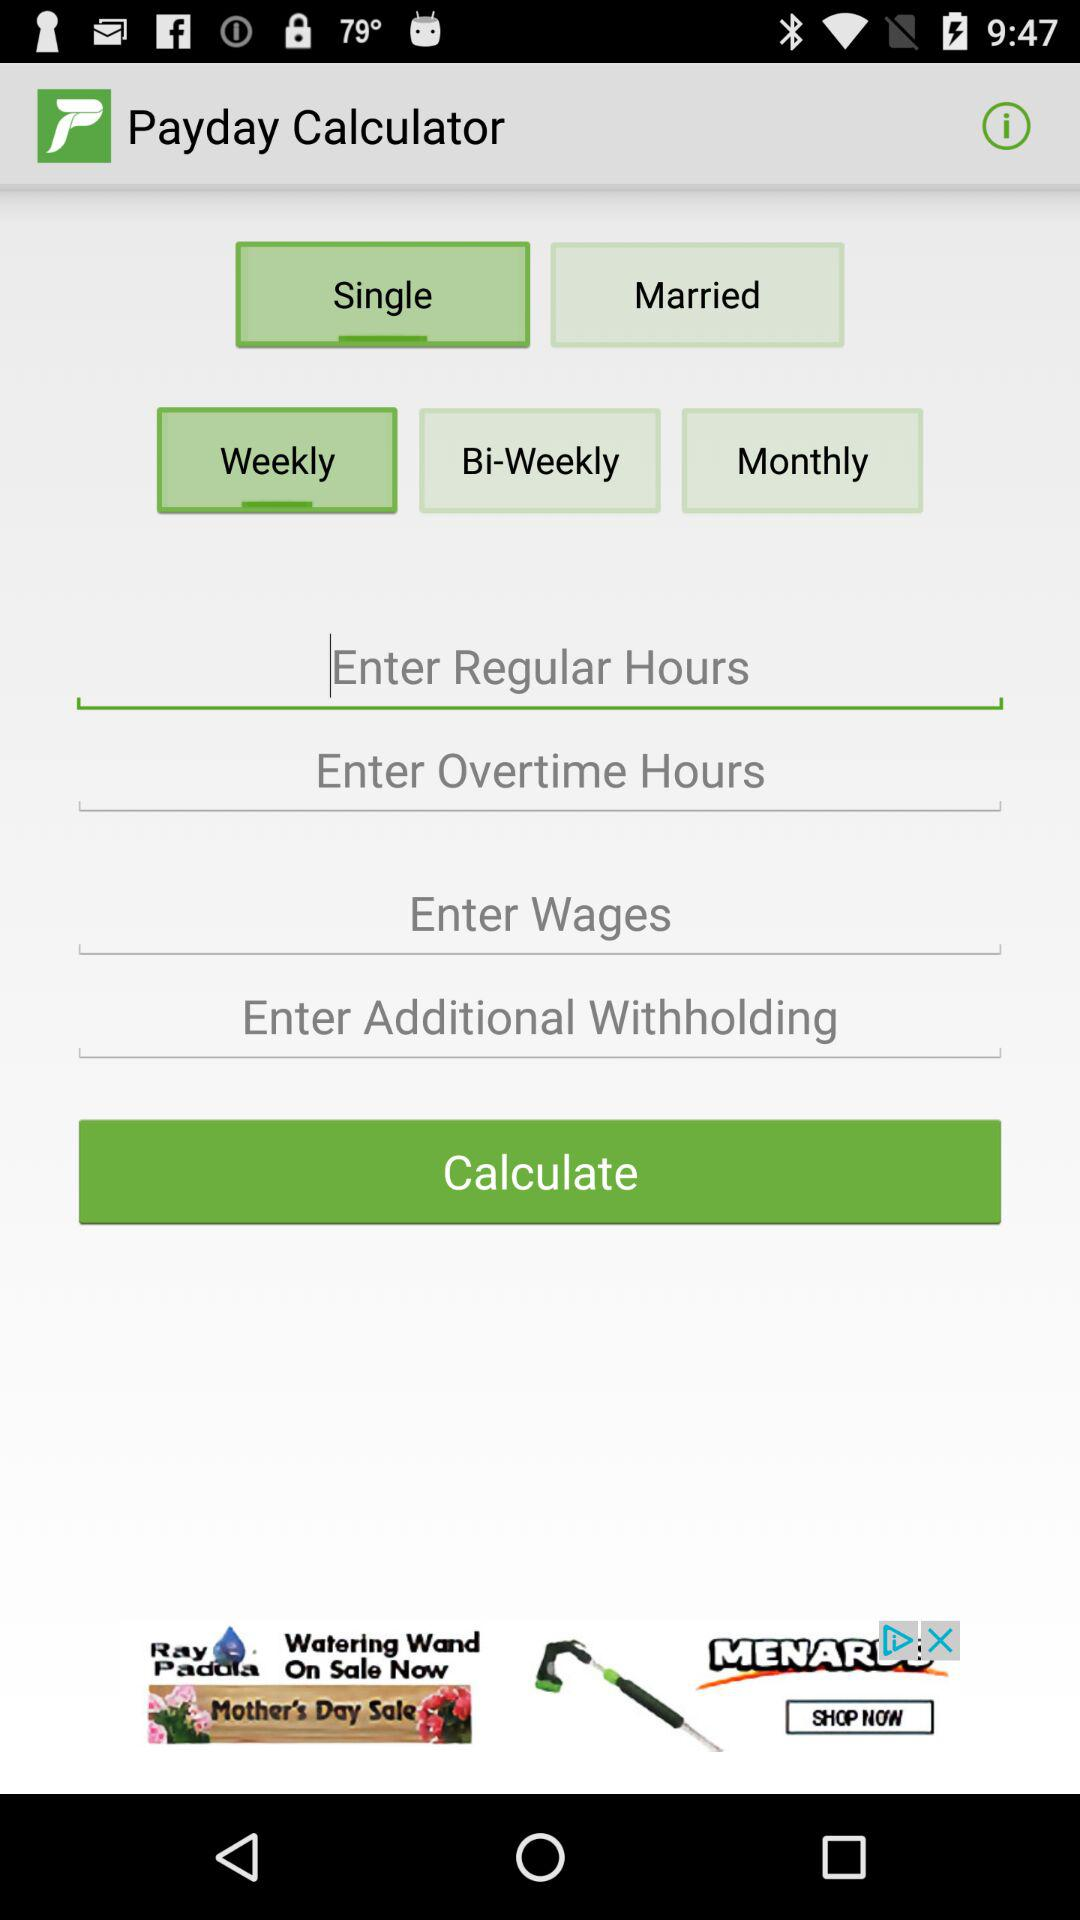What is the name of the application? The name of the application is "Payday Calculator". 